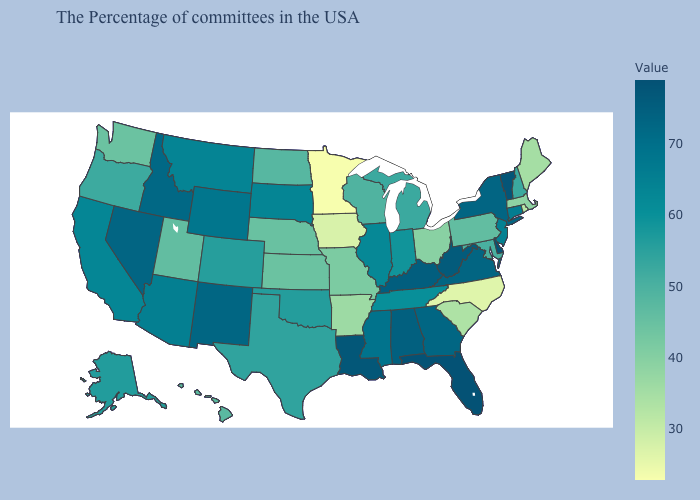Which states hav the highest value in the West?
Keep it brief. Nevada. Among the states that border California , does Nevada have the highest value?
Concise answer only. Yes. Which states hav the highest value in the MidWest?
Concise answer only. South Dakota. Does Massachusetts have the lowest value in the Northeast?
Keep it brief. No. Among the states that border Idaho , which have the highest value?
Quick response, please. Nevada. Does Vermont have a lower value than New Jersey?
Write a very short answer. No. 